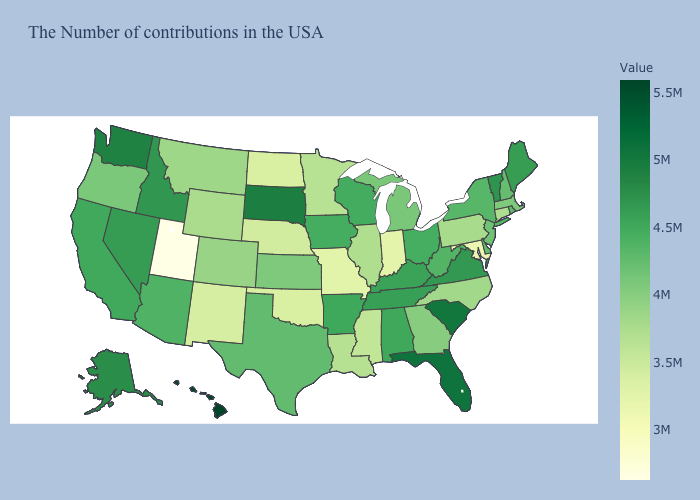Does New Jersey have the highest value in the Northeast?
Answer briefly. No. Does the map have missing data?
Keep it brief. No. Does New Hampshire have a lower value than Florida?
Keep it brief. Yes. Is the legend a continuous bar?
Answer briefly. Yes. Which states hav the highest value in the MidWest?
Give a very brief answer. South Dakota. Does Hawaii have the highest value in the USA?
Be succinct. Yes. Does Oregon have the lowest value in the USA?
Quick response, please. No. 